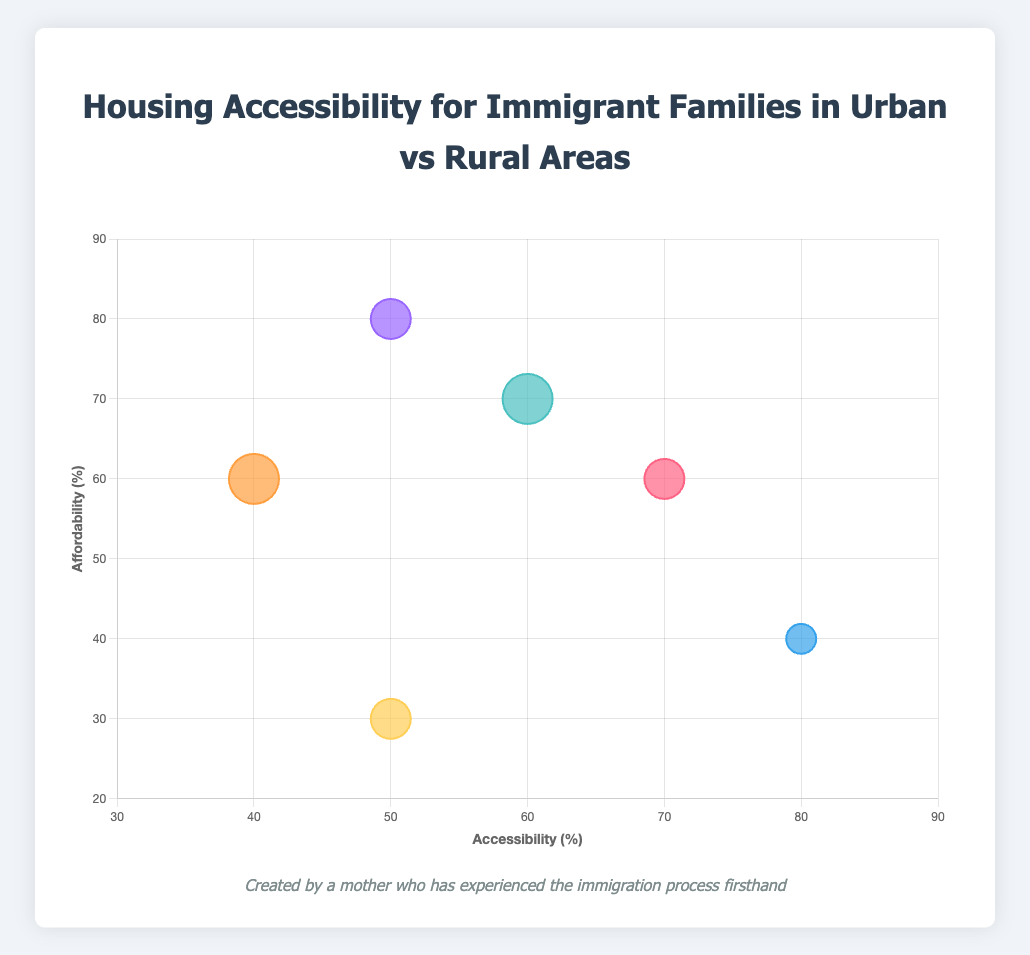What is the title of the chart? The title of the chart is displayed at the top and reads "Housing Accessibility for Immigrant Families in Urban vs Rural Areas".
Answer: Housing Accessibility for Immigrant Families in Urban vs Rural Areas How many housing types are represented in the bubble chart? The chart has six distinct bubbles, each representing a different type of housing.
Answer: Six Which housing type has the highest accessibility? By looking at the x-axis, we see that "Urban Private Rental" has the highest x-value, representing accessibility of 80%.
Answer: Urban Private Rental What is the accessibility and affordability of Rural Home Ownership? The bubble labeled "Rural Home Ownership" has coordinates (x: 40, y: 60), meaning accessibility is 40% and affordability is 60%.
Answer: Accessibility: 40%, Affordability: 60% Which type of housing has the largest average family size? The size of the bubbles represents the average family size, so the largest bubbles are "Rural Public Housing" and "Rural Home Ownership", both with an average family size of 5 (bubble radius is 25).
Answer: Rural Public Housing, Rural Home Ownership Which type of housing has the highest affordability? By looking at the y-axis, we see that "Rural Private Rental" has the highest y-value, representing affordability of 80%.
Answer: Rural Private Rental Compare the accessibility of Urban Public Housing and Rural Public Housing. "Urban Public Housing" has an accessibility of 70% (x: 70) and "Rural Public Housing" has an accessibility of 60% (x: 60).
Answer: Urban Public Housing: 70%, Rural Public Housing: 60% Which housing type has the least affordable option? Looking at the y-axis, "Urban Home Ownership" has the lowest y-value, representing affordability of 30%.
Answer: Urban Home Ownership Is there any housing type with both high affordability and high accessibility? We would look for a bubble with high values on both x and y axes. "Urban Private Rental" has high accessibility (80%) but low affordability (40%). "Rural Private Rental" has high affordability (80%) but moderate accessibility (50%). No housing type has both high values.
Answer: No What is the average family size for "Urban Private Rental"? The size of the bubble for "Urban Private Rental" corresponds to an average family size of 3 (bubble radius is 15).
Answer: 3 